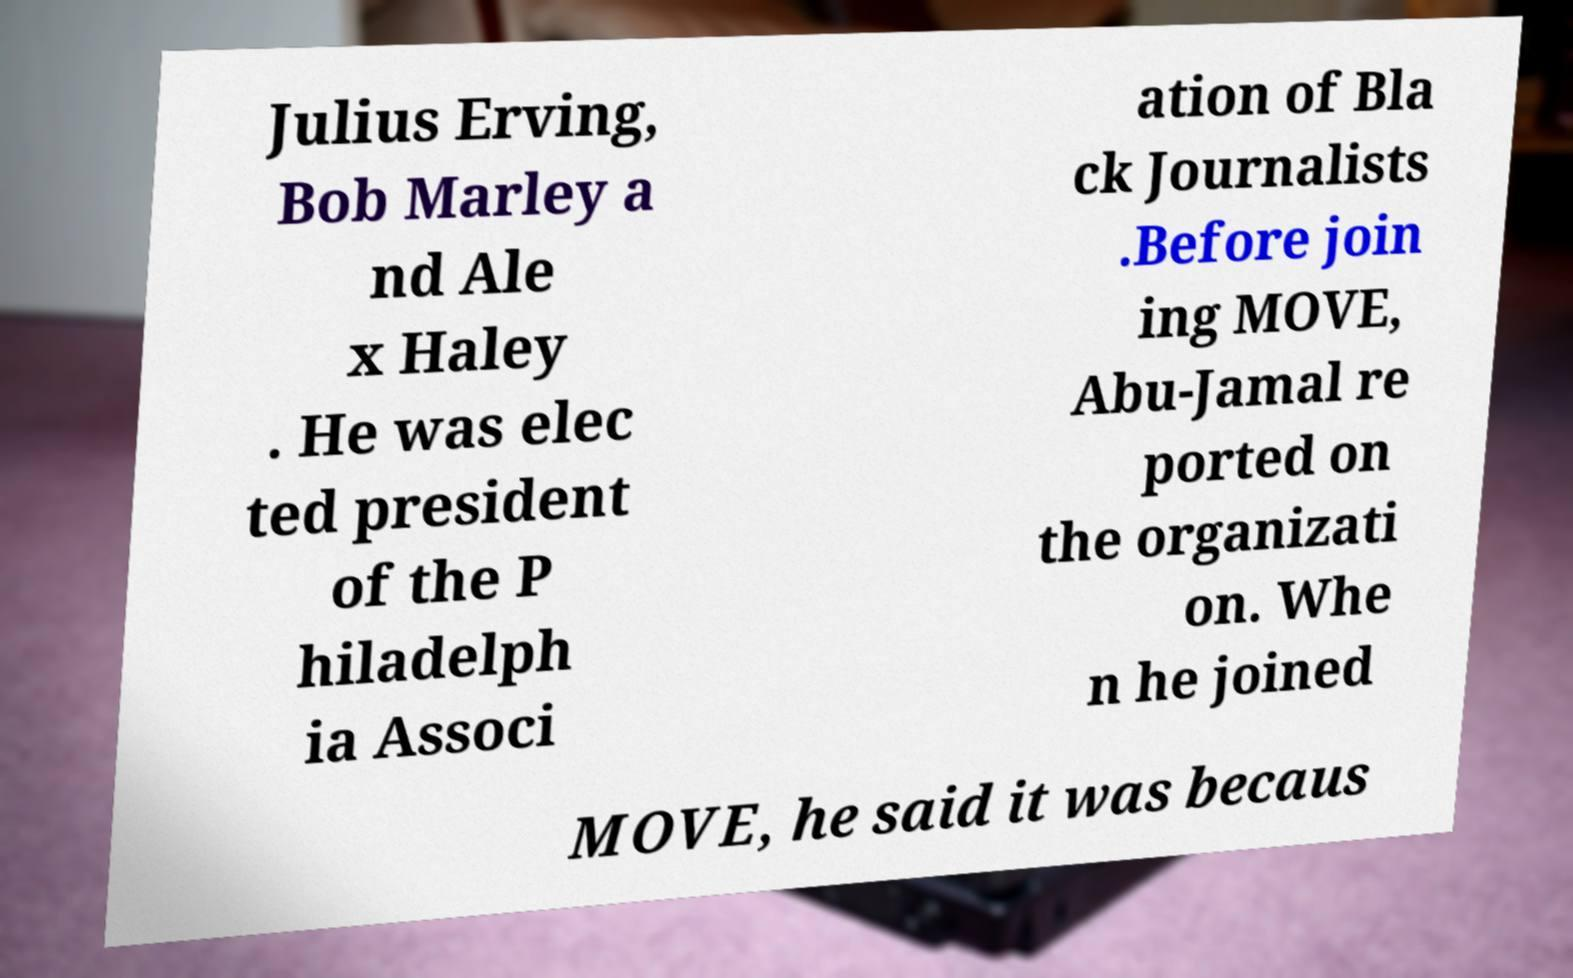I need the written content from this picture converted into text. Can you do that? Julius Erving, Bob Marley a nd Ale x Haley . He was elec ted president of the P hiladelph ia Associ ation of Bla ck Journalists .Before join ing MOVE, Abu-Jamal re ported on the organizati on. Whe n he joined MOVE, he said it was becaus 